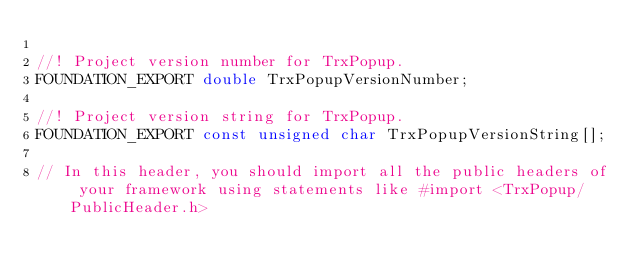Convert code to text. <code><loc_0><loc_0><loc_500><loc_500><_C_>
//! Project version number for TrxPopup.
FOUNDATION_EXPORT double TrxPopupVersionNumber;

//! Project version string for TrxPopup.
FOUNDATION_EXPORT const unsigned char TrxPopupVersionString[];

// In this header, you should import all the public headers of your framework using statements like #import <TrxPopup/PublicHeader.h>


</code> 